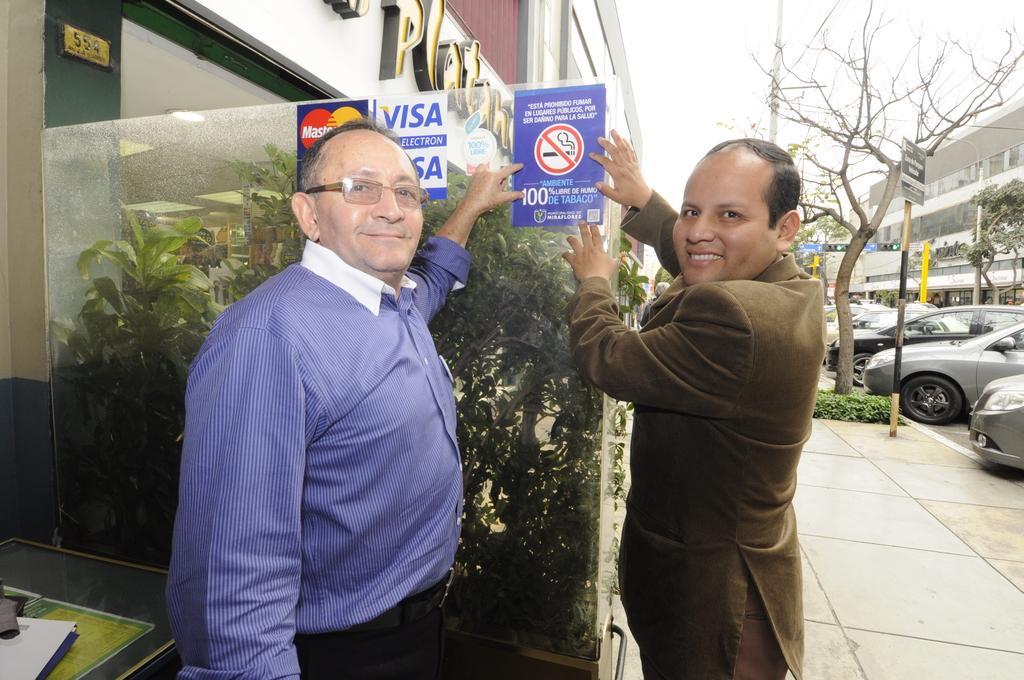Could you give a brief overview of what you see in this image? In this image we can see this person wearing blue shirt and spectacles and this person wearing blazer are smiling and standing on the road. Here we can see the table on which we can see few objects are kept, here we can see the glass door on which we can see posters, we can see plants, buildings, trees, boards, cars parked here and the sky in the background. 